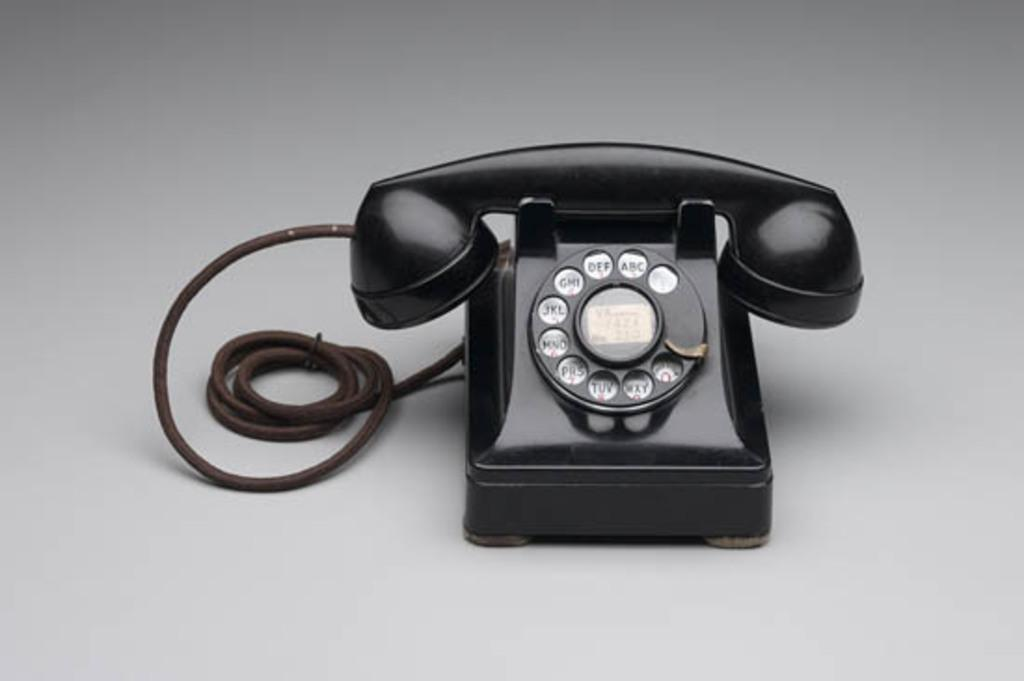What object can be seen in the image? There is a telephone in the image. What type of fruit is displayed in the shop in the image? There is no fruit or shop present in the image; it only features a telephone. What type of insurance is being advertised on the telephone in the image? There is no advertisement or insurance information present on the telephone in the image. 